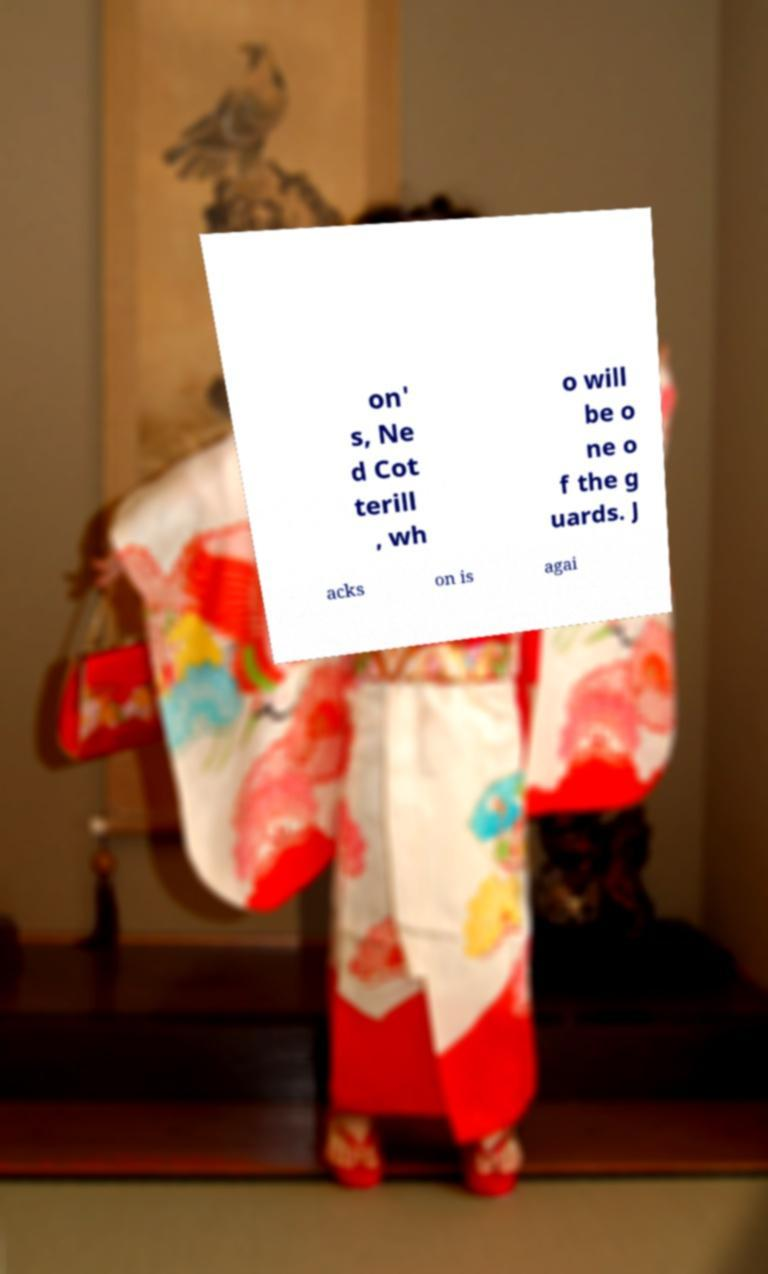Please identify and transcribe the text found in this image. on' s, Ne d Cot terill , wh o will be o ne o f the g uards. J acks on is agai 